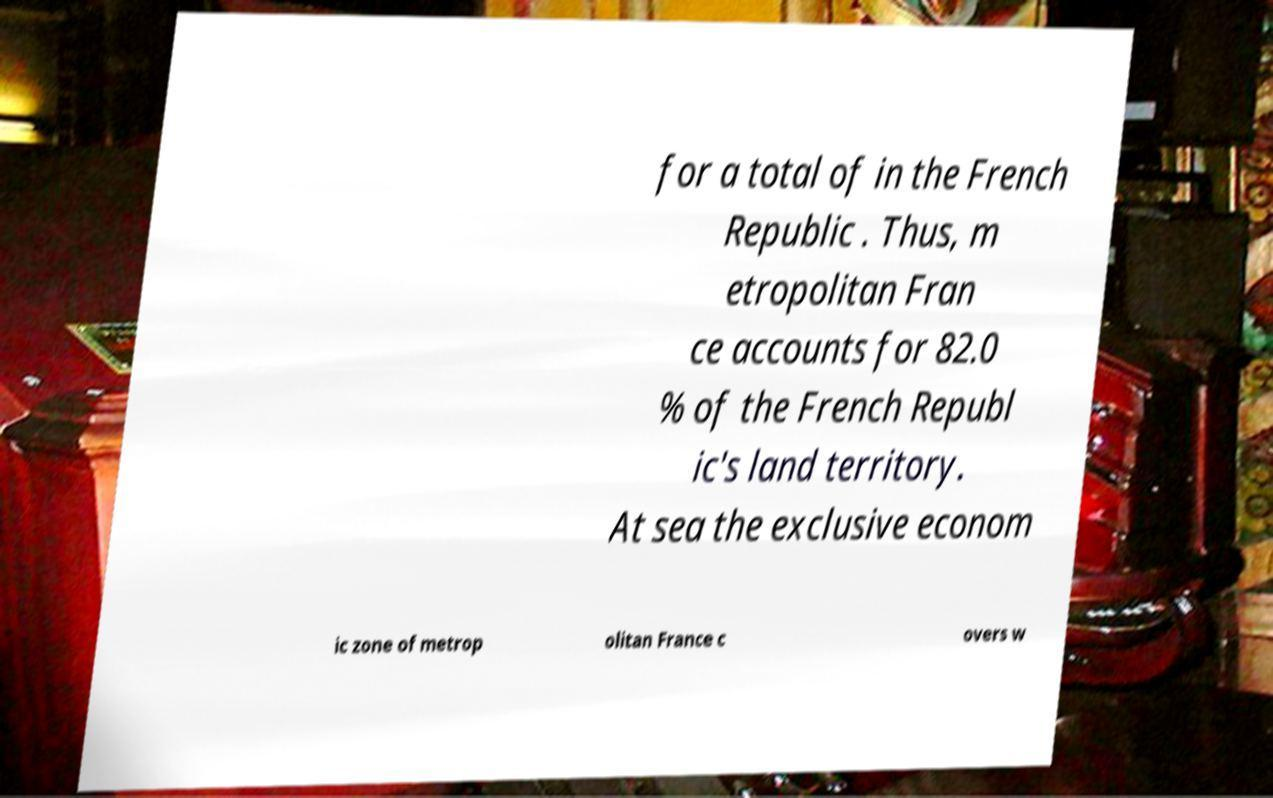Can you accurately transcribe the text from the provided image for me? for a total of in the French Republic . Thus, m etropolitan Fran ce accounts for 82.0 % of the French Republ ic's land territory. At sea the exclusive econom ic zone of metrop olitan France c overs w 